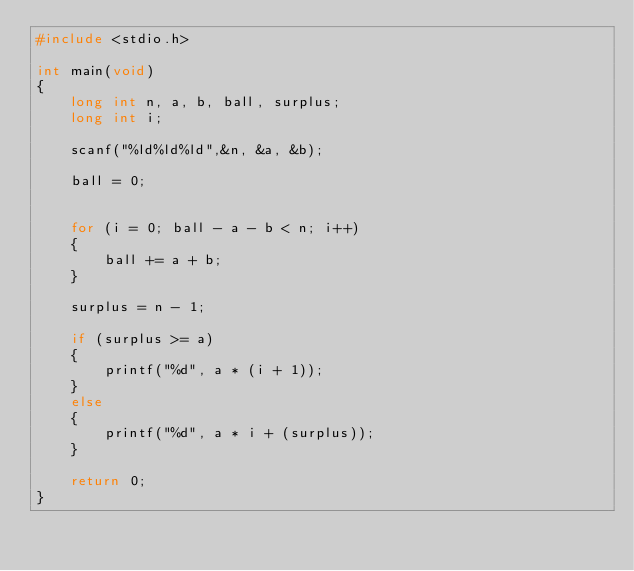Convert code to text. <code><loc_0><loc_0><loc_500><loc_500><_C_>#include <stdio.h>

int main(void)
{
	long int n, a, b, ball, surplus;
	long int i;

	scanf("%ld%ld%ld",&n, &a, &b);
	
	ball = 0;


	for (i = 0; ball - a - b < n; i++)
	{
		ball += a + b;
	}

	surplus = n - 1;

	if (surplus >= a)
	{
		printf("%d", a * (i + 1));
	}
	else
	{
		printf("%d", a * i + (surplus));
	}

	return 0;
}</code> 